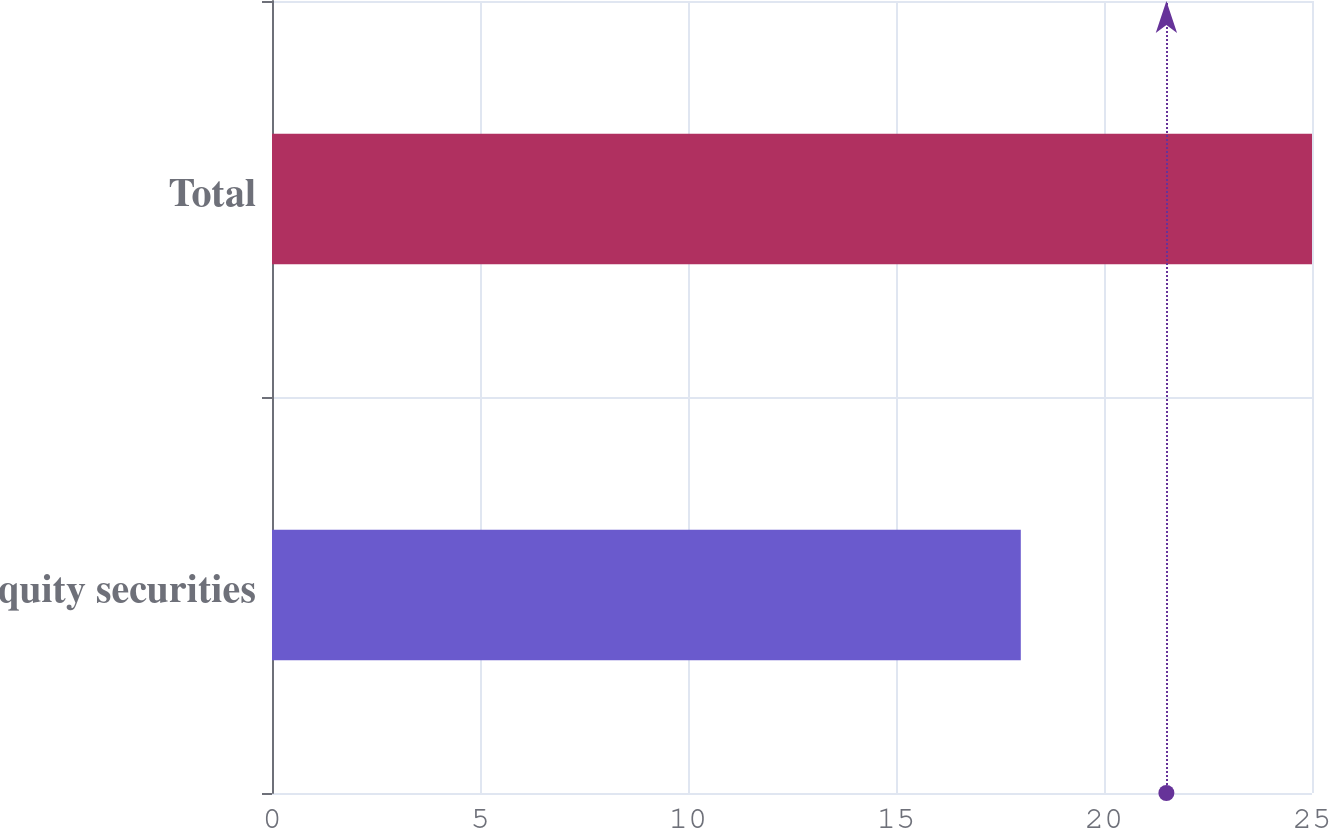Convert chart to OTSL. <chart><loc_0><loc_0><loc_500><loc_500><bar_chart><fcel>Equity securities<fcel>Total<nl><fcel>18<fcel>25<nl></chart> 